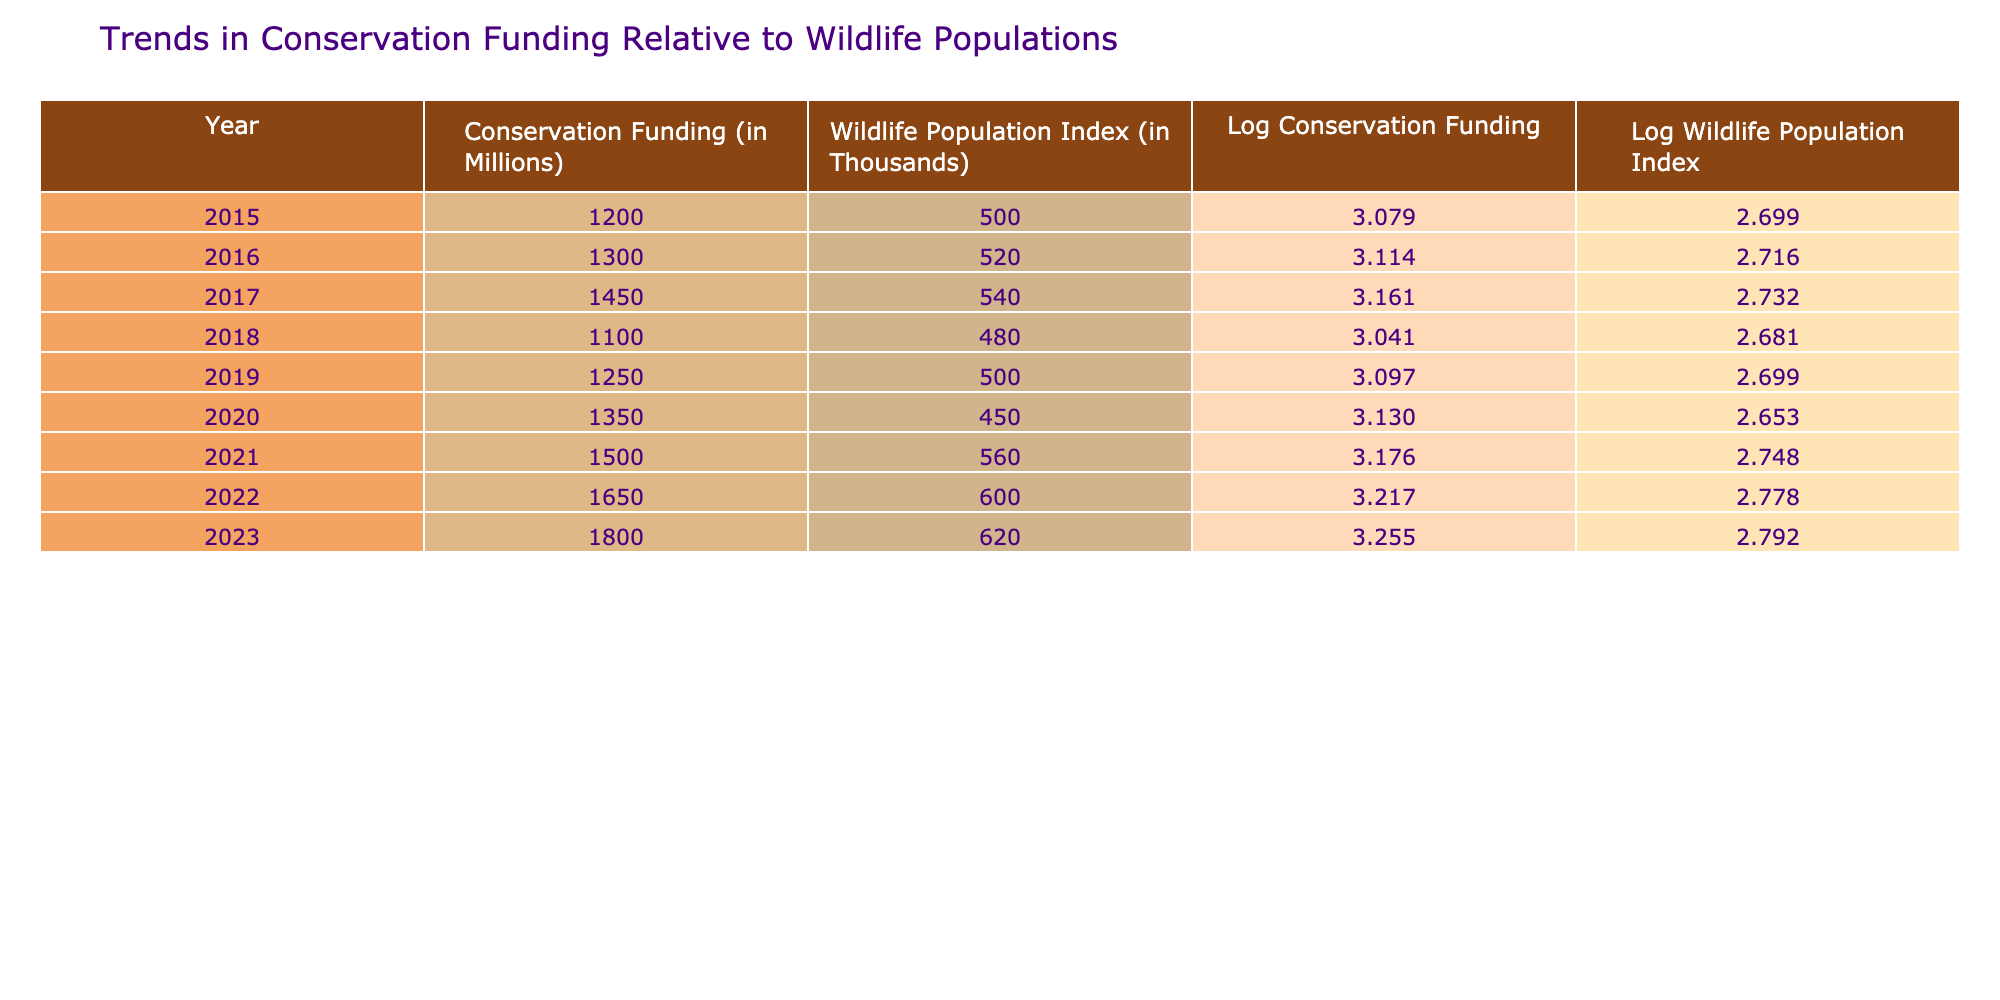What was the conservation funding in 2020? In the table, under the year 2020, the conservation funding is listed as 1350 million.
Answer: 1350 million What is the wildlife population index for the year 2022? Referring to the table for the year 2022, the wildlife population index is given as 600 thousand.
Answer: 600 thousand What is the difference in conservation funding between 2015 and 2023? In 2015, the conservation funding was 1200 million and in 2023 it is 1800 million. The difference is 1800 - 1200 = 600 million.
Answer: 600 million What was the average wildlife population index from 2015 to 2023? To find the average, we need to sum the wildlife population index values from 2015 to 2023, which are 500, 520, 540, 480, 500, 450, 560, 600, and 620. The sum is 500 + 520 + 540 + 480 + 500 + 450 + 560 + 600 + 620 = 4620. We divide this sum by the number of years (9), which gives 4620 / 9 ≈ 513.33 thousand.
Answer: Approximately 513.33 thousand Is there a year where conservation funding decreased from the previous year? Reviewing the table, we can see that in 2018, the conservation funding dropped from 1450 million in 2017 to 1100 million. So, yes, there is such a year.
Answer: Yes Which year had the highest conservation funding, and what was that amount? Looking through the table, the highest conservation funding recorded is in 2023 at 1800 million.
Answer: 2023, 1800 million What was the trend in wildlife population index from 2015 to 2023? By examining the wildlife population index values from 2015 through 2023, we can see they are 500, 520, 540, 480, 500, 450, 560, 600, and 620. The trend indicates fluctuations with an overall increase toward 2023, despite some decreases in certain years.
Answer: Increasing overall What is the logarithmic value of the conservation funding for 2019? The conservation funding for 2019 is 1250 million. The logarithmic value is calculated as log10(1250) ≈ 3.097.
Answer: Approximately 3.097 What was the year with the lowest wildlife population index? From the table data, 2020 has the lowest wildlife population index listed at 450 thousand.
Answer: 2020 How many years had conservation funding greater than 1400 million? Checking the values for conservation funding, the years with funding greater than 1400 million are 2017, 2021, 2022, and 2023, totaling 4 years.
Answer: 4 years 